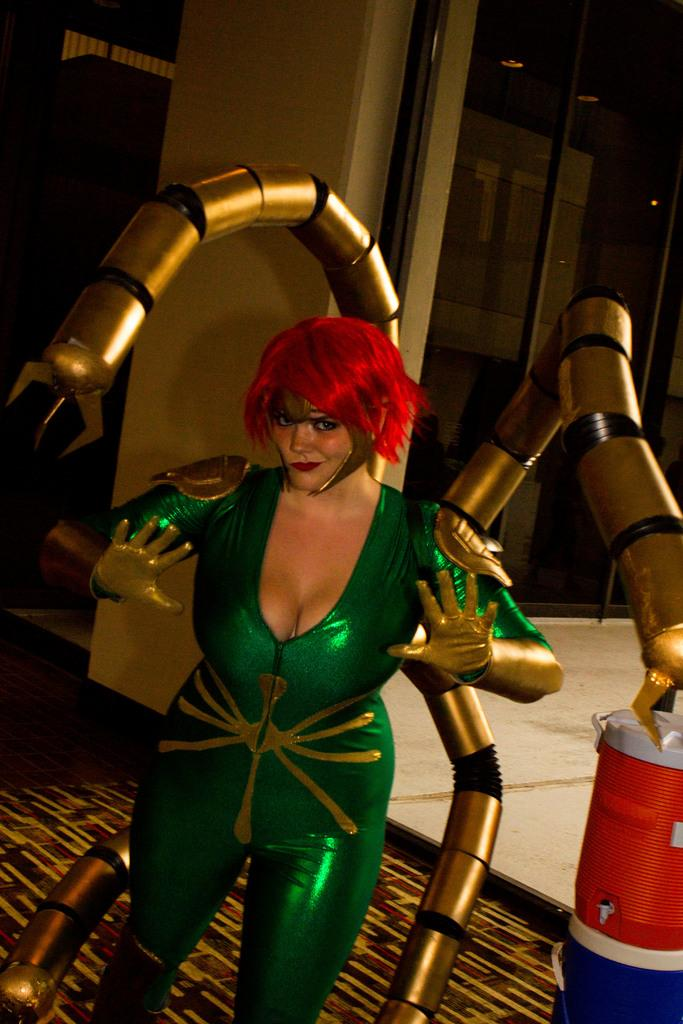What is the person in the image wearing? There is a person wearing a fancy dress in the image. What object can be seen in the bottom right corner of the image? There is a drum in the bottom right of the image. What structure is located in the middle of the image? There is a pillar in the middle of the image. What type of crack is visible on the drum in the image? There is no crack visible on the drum in the image. Can you see a chicken in the image? There is no chicken present in the image. 